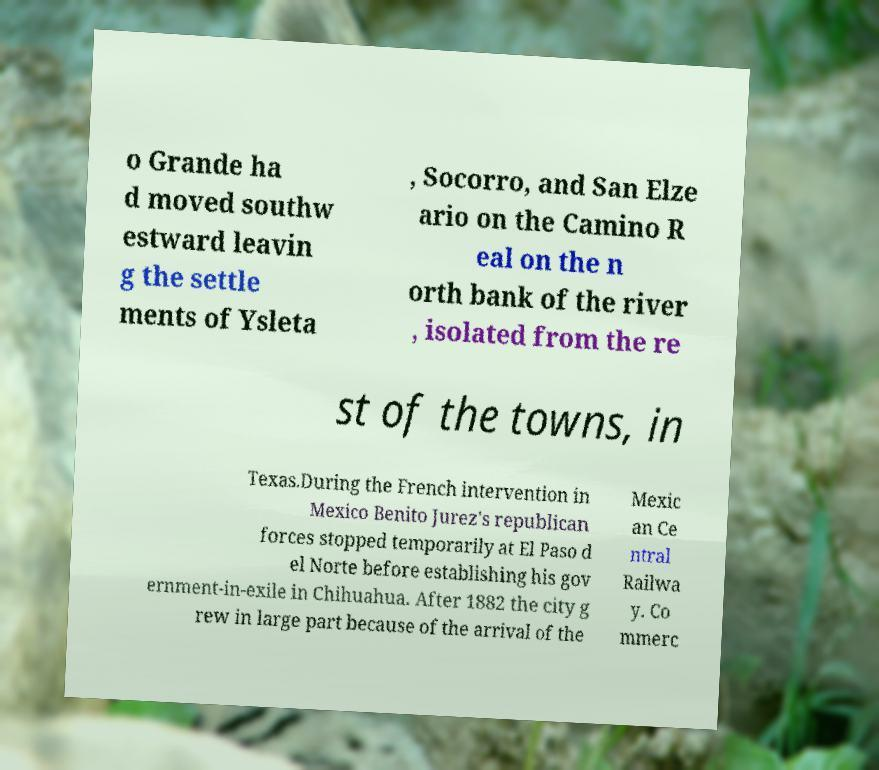Please identify and transcribe the text found in this image. o Grande ha d moved southw estward leavin g the settle ments of Ysleta , Socorro, and San Elze ario on the Camino R eal on the n orth bank of the river , isolated from the re st of the towns, in Texas.During the French intervention in Mexico Benito Jurez's republican forces stopped temporarily at El Paso d el Norte before establishing his gov ernment-in-exile in Chihuahua. After 1882 the city g rew in large part because of the arrival of the Mexic an Ce ntral Railwa y. Co mmerc 